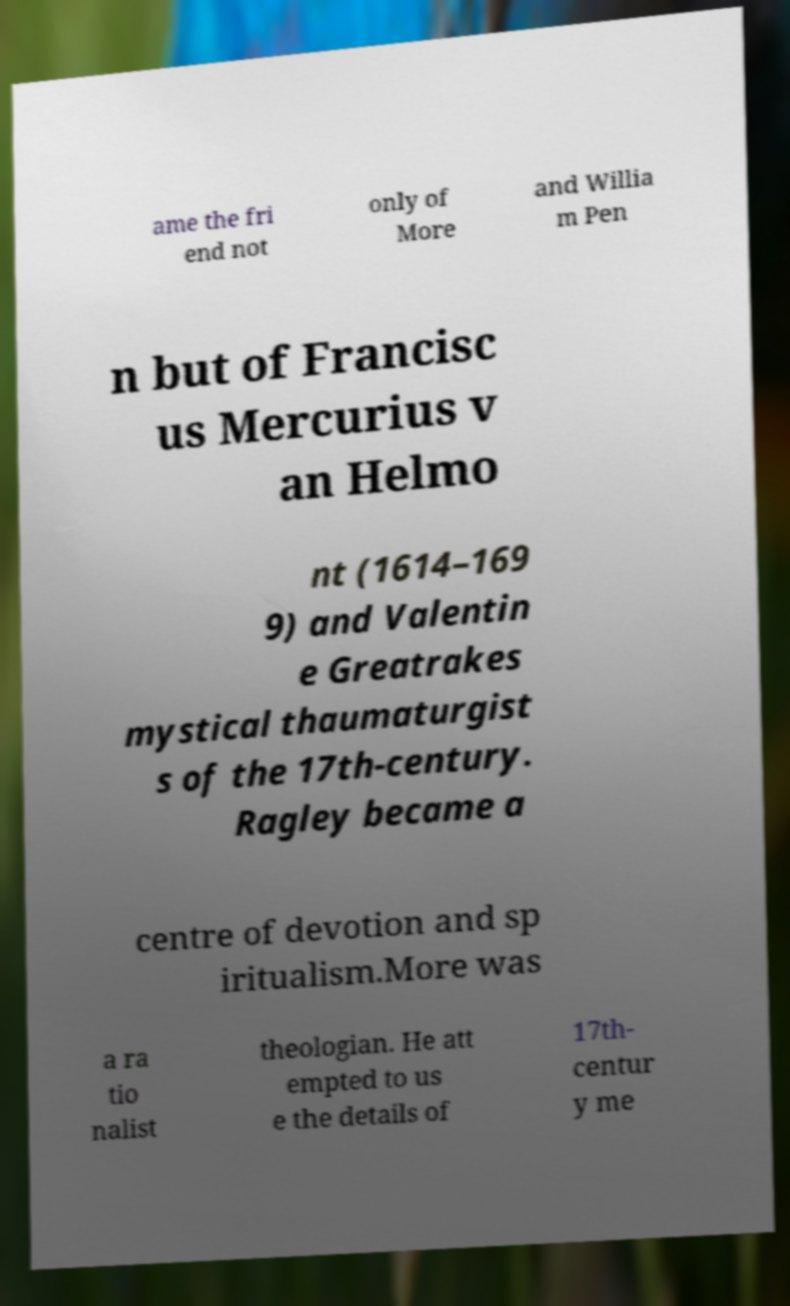Please identify and transcribe the text found in this image. ame the fri end not only of More and Willia m Pen n but of Francisc us Mercurius v an Helmo nt (1614–169 9) and Valentin e Greatrakes mystical thaumaturgist s of the 17th-century. Ragley became a centre of devotion and sp iritualism.More was a ra tio nalist theologian. He att empted to us e the details of 17th- centur y me 